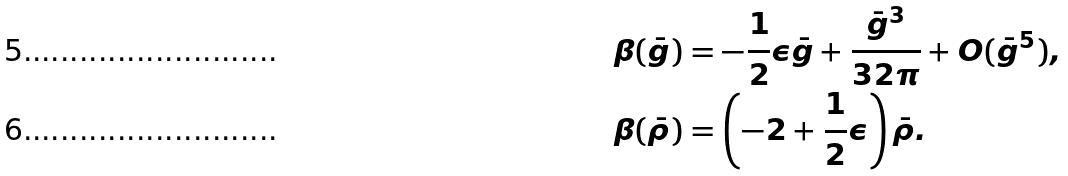<formula> <loc_0><loc_0><loc_500><loc_500>\beta ( \bar { g } ) & = - \frac { 1 } { 2 } \epsilon \bar { g } + \frac { \bar { g } ^ { 3 } } { 3 2 \pi } + O ( \bar { g } ^ { 5 } ) , \\ \beta ( \bar { \rho } ) & = \left ( - 2 + \frac { 1 } { 2 } \epsilon \right ) \bar { \rho } .</formula> 